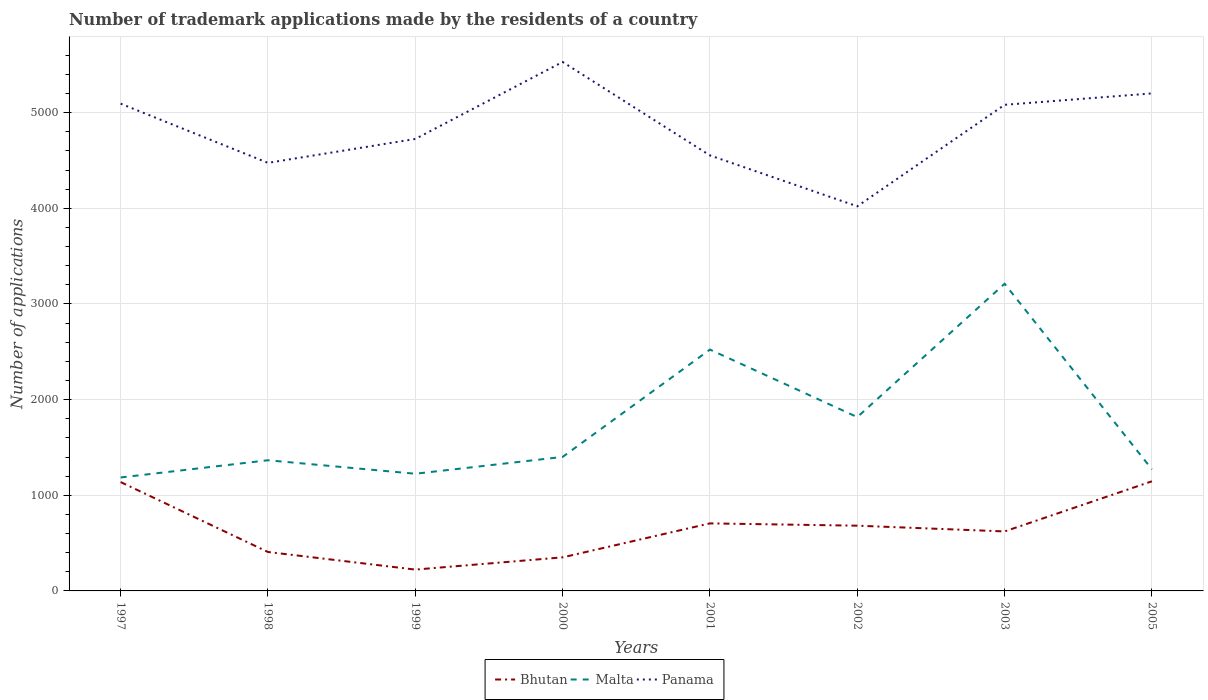How many different coloured lines are there?
Keep it short and to the point. 3. Does the line corresponding to Panama intersect with the line corresponding to Bhutan?
Your answer should be compact. No. Across all years, what is the maximum number of trademark applications made by the residents in Panama?
Your answer should be very brief. 4021. What is the total number of trademark applications made by the residents in Panama in the graph?
Make the answer very short. -726. What is the difference between the highest and the second highest number of trademark applications made by the residents in Panama?
Make the answer very short. 1509. How many years are there in the graph?
Offer a terse response. 8. What is the difference between two consecutive major ticks on the Y-axis?
Your answer should be very brief. 1000. How are the legend labels stacked?
Provide a short and direct response. Horizontal. What is the title of the graph?
Your response must be concise. Number of trademark applications made by the residents of a country. What is the label or title of the X-axis?
Make the answer very short. Years. What is the label or title of the Y-axis?
Offer a terse response. Number of applications. What is the Number of applications in Bhutan in 1997?
Give a very brief answer. 1138. What is the Number of applications in Malta in 1997?
Offer a terse response. 1186. What is the Number of applications in Panama in 1997?
Offer a terse response. 5094. What is the Number of applications in Bhutan in 1998?
Make the answer very short. 407. What is the Number of applications of Malta in 1998?
Offer a very short reply. 1366. What is the Number of applications in Panama in 1998?
Ensure brevity in your answer.  4475. What is the Number of applications of Bhutan in 1999?
Provide a succinct answer. 223. What is the Number of applications of Malta in 1999?
Give a very brief answer. 1225. What is the Number of applications of Panama in 1999?
Provide a succinct answer. 4725. What is the Number of applications of Bhutan in 2000?
Provide a succinct answer. 351. What is the Number of applications in Malta in 2000?
Your answer should be compact. 1401. What is the Number of applications of Panama in 2000?
Your answer should be compact. 5530. What is the Number of applications in Bhutan in 2001?
Offer a terse response. 706. What is the Number of applications of Malta in 2001?
Make the answer very short. 2523. What is the Number of applications in Panama in 2001?
Make the answer very short. 4553. What is the Number of applications of Bhutan in 2002?
Provide a succinct answer. 682. What is the Number of applications of Malta in 2002?
Your answer should be very brief. 1817. What is the Number of applications of Panama in 2002?
Make the answer very short. 4021. What is the Number of applications of Bhutan in 2003?
Keep it short and to the point. 622. What is the Number of applications of Malta in 2003?
Keep it short and to the point. 3211. What is the Number of applications in Panama in 2003?
Your answer should be compact. 5082. What is the Number of applications of Bhutan in 2005?
Provide a succinct answer. 1146. What is the Number of applications of Malta in 2005?
Make the answer very short. 1271. What is the Number of applications in Panama in 2005?
Give a very brief answer. 5201. Across all years, what is the maximum Number of applications of Bhutan?
Provide a succinct answer. 1146. Across all years, what is the maximum Number of applications of Malta?
Make the answer very short. 3211. Across all years, what is the maximum Number of applications of Panama?
Keep it short and to the point. 5530. Across all years, what is the minimum Number of applications in Bhutan?
Give a very brief answer. 223. Across all years, what is the minimum Number of applications in Malta?
Offer a very short reply. 1186. Across all years, what is the minimum Number of applications of Panama?
Your response must be concise. 4021. What is the total Number of applications of Bhutan in the graph?
Offer a very short reply. 5275. What is the total Number of applications in Malta in the graph?
Provide a short and direct response. 1.40e+04. What is the total Number of applications in Panama in the graph?
Ensure brevity in your answer.  3.87e+04. What is the difference between the Number of applications of Bhutan in 1997 and that in 1998?
Provide a short and direct response. 731. What is the difference between the Number of applications in Malta in 1997 and that in 1998?
Your answer should be very brief. -180. What is the difference between the Number of applications of Panama in 1997 and that in 1998?
Your response must be concise. 619. What is the difference between the Number of applications in Bhutan in 1997 and that in 1999?
Your answer should be compact. 915. What is the difference between the Number of applications of Malta in 1997 and that in 1999?
Your answer should be compact. -39. What is the difference between the Number of applications of Panama in 1997 and that in 1999?
Give a very brief answer. 369. What is the difference between the Number of applications in Bhutan in 1997 and that in 2000?
Your answer should be very brief. 787. What is the difference between the Number of applications of Malta in 1997 and that in 2000?
Make the answer very short. -215. What is the difference between the Number of applications in Panama in 1997 and that in 2000?
Ensure brevity in your answer.  -436. What is the difference between the Number of applications of Bhutan in 1997 and that in 2001?
Ensure brevity in your answer.  432. What is the difference between the Number of applications of Malta in 1997 and that in 2001?
Ensure brevity in your answer.  -1337. What is the difference between the Number of applications in Panama in 1997 and that in 2001?
Provide a short and direct response. 541. What is the difference between the Number of applications in Bhutan in 1997 and that in 2002?
Provide a succinct answer. 456. What is the difference between the Number of applications in Malta in 1997 and that in 2002?
Make the answer very short. -631. What is the difference between the Number of applications of Panama in 1997 and that in 2002?
Make the answer very short. 1073. What is the difference between the Number of applications of Bhutan in 1997 and that in 2003?
Provide a succinct answer. 516. What is the difference between the Number of applications in Malta in 1997 and that in 2003?
Make the answer very short. -2025. What is the difference between the Number of applications of Bhutan in 1997 and that in 2005?
Provide a succinct answer. -8. What is the difference between the Number of applications in Malta in 1997 and that in 2005?
Ensure brevity in your answer.  -85. What is the difference between the Number of applications of Panama in 1997 and that in 2005?
Provide a short and direct response. -107. What is the difference between the Number of applications of Bhutan in 1998 and that in 1999?
Ensure brevity in your answer.  184. What is the difference between the Number of applications in Malta in 1998 and that in 1999?
Keep it short and to the point. 141. What is the difference between the Number of applications in Panama in 1998 and that in 1999?
Give a very brief answer. -250. What is the difference between the Number of applications of Malta in 1998 and that in 2000?
Ensure brevity in your answer.  -35. What is the difference between the Number of applications in Panama in 1998 and that in 2000?
Keep it short and to the point. -1055. What is the difference between the Number of applications in Bhutan in 1998 and that in 2001?
Offer a very short reply. -299. What is the difference between the Number of applications in Malta in 1998 and that in 2001?
Offer a terse response. -1157. What is the difference between the Number of applications of Panama in 1998 and that in 2001?
Your response must be concise. -78. What is the difference between the Number of applications in Bhutan in 1998 and that in 2002?
Your response must be concise. -275. What is the difference between the Number of applications in Malta in 1998 and that in 2002?
Your answer should be very brief. -451. What is the difference between the Number of applications of Panama in 1998 and that in 2002?
Provide a succinct answer. 454. What is the difference between the Number of applications in Bhutan in 1998 and that in 2003?
Your answer should be compact. -215. What is the difference between the Number of applications of Malta in 1998 and that in 2003?
Offer a very short reply. -1845. What is the difference between the Number of applications in Panama in 1998 and that in 2003?
Your answer should be compact. -607. What is the difference between the Number of applications in Bhutan in 1998 and that in 2005?
Your answer should be compact. -739. What is the difference between the Number of applications of Malta in 1998 and that in 2005?
Make the answer very short. 95. What is the difference between the Number of applications in Panama in 1998 and that in 2005?
Offer a very short reply. -726. What is the difference between the Number of applications of Bhutan in 1999 and that in 2000?
Your answer should be very brief. -128. What is the difference between the Number of applications in Malta in 1999 and that in 2000?
Your response must be concise. -176. What is the difference between the Number of applications in Panama in 1999 and that in 2000?
Keep it short and to the point. -805. What is the difference between the Number of applications in Bhutan in 1999 and that in 2001?
Your response must be concise. -483. What is the difference between the Number of applications in Malta in 1999 and that in 2001?
Make the answer very short. -1298. What is the difference between the Number of applications of Panama in 1999 and that in 2001?
Your answer should be very brief. 172. What is the difference between the Number of applications in Bhutan in 1999 and that in 2002?
Make the answer very short. -459. What is the difference between the Number of applications of Malta in 1999 and that in 2002?
Your response must be concise. -592. What is the difference between the Number of applications in Panama in 1999 and that in 2002?
Provide a short and direct response. 704. What is the difference between the Number of applications of Bhutan in 1999 and that in 2003?
Offer a very short reply. -399. What is the difference between the Number of applications of Malta in 1999 and that in 2003?
Make the answer very short. -1986. What is the difference between the Number of applications in Panama in 1999 and that in 2003?
Your answer should be compact. -357. What is the difference between the Number of applications in Bhutan in 1999 and that in 2005?
Keep it short and to the point. -923. What is the difference between the Number of applications of Malta in 1999 and that in 2005?
Your response must be concise. -46. What is the difference between the Number of applications in Panama in 1999 and that in 2005?
Provide a succinct answer. -476. What is the difference between the Number of applications in Bhutan in 2000 and that in 2001?
Give a very brief answer. -355. What is the difference between the Number of applications in Malta in 2000 and that in 2001?
Provide a succinct answer. -1122. What is the difference between the Number of applications in Panama in 2000 and that in 2001?
Make the answer very short. 977. What is the difference between the Number of applications in Bhutan in 2000 and that in 2002?
Provide a short and direct response. -331. What is the difference between the Number of applications of Malta in 2000 and that in 2002?
Provide a succinct answer. -416. What is the difference between the Number of applications in Panama in 2000 and that in 2002?
Offer a very short reply. 1509. What is the difference between the Number of applications of Bhutan in 2000 and that in 2003?
Your answer should be very brief. -271. What is the difference between the Number of applications of Malta in 2000 and that in 2003?
Keep it short and to the point. -1810. What is the difference between the Number of applications in Panama in 2000 and that in 2003?
Provide a succinct answer. 448. What is the difference between the Number of applications in Bhutan in 2000 and that in 2005?
Ensure brevity in your answer.  -795. What is the difference between the Number of applications in Malta in 2000 and that in 2005?
Give a very brief answer. 130. What is the difference between the Number of applications of Panama in 2000 and that in 2005?
Offer a terse response. 329. What is the difference between the Number of applications of Bhutan in 2001 and that in 2002?
Your response must be concise. 24. What is the difference between the Number of applications in Malta in 2001 and that in 2002?
Provide a succinct answer. 706. What is the difference between the Number of applications in Panama in 2001 and that in 2002?
Your answer should be compact. 532. What is the difference between the Number of applications of Bhutan in 2001 and that in 2003?
Offer a terse response. 84. What is the difference between the Number of applications of Malta in 2001 and that in 2003?
Provide a short and direct response. -688. What is the difference between the Number of applications of Panama in 2001 and that in 2003?
Your answer should be very brief. -529. What is the difference between the Number of applications of Bhutan in 2001 and that in 2005?
Your response must be concise. -440. What is the difference between the Number of applications in Malta in 2001 and that in 2005?
Give a very brief answer. 1252. What is the difference between the Number of applications of Panama in 2001 and that in 2005?
Give a very brief answer. -648. What is the difference between the Number of applications in Malta in 2002 and that in 2003?
Your response must be concise. -1394. What is the difference between the Number of applications in Panama in 2002 and that in 2003?
Offer a very short reply. -1061. What is the difference between the Number of applications in Bhutan in 2002 and that in 2005?
Ensure brevity in your answer.  -464. What is the difference between the Number of applications in Malta in 2002 and that in 2005?
Keep it short and to the point. 546. What is the difference between the Number of applications of Panama in 2002 and that in 2005?
Your response must be concise. -1180. What is the difference between the Number of applications of Bhutan in 2003 and that in 2005?
Ensure brevity in your answer.  -524. What is the difference between the Number of applications in Malta in 2003 and that in 2005?
Offer a terse response. 1940. What is the difference between the Number of applications of Panama in 2003 and that in 2005?
Your answer should be very brief. -119. What is the difference between the Number of applications in Bhutan in 1997 and the Number of applications in Malta in 1998?
Keep it short and to the point. -228. What is the difference between the Number of applications in Bhutan in 1997 and the Number of applications in Panama in 1998?
Ensure brevity in your answer.  -3337. What is the difference between the Number of applications of Malta in 1997 and the Number of applications of Panama in 1998?
Ensure brevity in your answer.  -3289. What is the difference between the Number of applications of Bhutan in 1997 and the Number of applications of Malta in 1999?
Your answer should be very brief. -87. What is the difference between the Number of applications of Bhutan in 1997 and the Number of applications of Panama in 1999?
Offer a very short reply. -3587. What is the difference between the Number of applications in Malta in 1997 and the Number of applications in Panama in 1999?
Provide a succinct answer. -3539. What is the difference between the Number of applications of Bhutan in 1997 and the Number of applications of Malta in 2000?
Offer a terse response. -263. What is the difference between the Number of applications of Bhutan in 1997 and the Number of applications of Panama in 2000?
Ensure brevity in your answer.  -4392. What is the difference between the Number of applications of Malta in 1997 and the Number of applications of Panama in 2000?
Your answer should be very brief. -4344. What is the difference between the Number of applications in Bhutan in 1997 and the Number of applications in Malta in 2001?
Make the answer very short. -1385. What is the difference between the Number of applications of Bhutan in 1997 and the Number of applications of Panama in 2001?
Provide a succinct answer. -3415. What is the difference between the Number of applications in Malta in 1997 and the Number of applications in Panama in 2001?
Make the answer very short. -3367. What is the difference between the Number of applications in Bhutan in 1997 and the Number of applications in Malta in 2002?
Offer a very short reply. -679. What is the difference between the Number of applications of Bhutan in 1997 and the Number of applications of Panama in 2002?
Provide a short and direct response. -2883. What is the difference between the Number of applications of Malta in 1997 and the Number of applications of Panama in 2002?
Provide a succinct answer. -2835. What is the difference between the Number of applications of Bhutan in 1997 and the Number of applications of Malta in 2003?
Offer a very short reply. -2073. What is the difference between the Number of applications in Bhutan in 1997 and the Number of applications in Panama in 2003?
Keep it short and to the point. -3944. What is the difference between the Number of applications of Malta in 1997 and the Number of applications of Panama in 2003?
Offer a terse response. -3896. What is the difference between the Number of applications of Bhutan in 1997 and the Number of applications of Malta in 2005?
Offer a very short reply. -133. What is the difference between the Number of applications of Bhutan in 1997 and the Number of applications of Panama in 2005?
Make the answer very short. -4063. What is the difference between the Number of applications of Malta in 1997 and the Number of applications of Panama in 2005?
Give a very brief answer. -4015. What is the difference between the Number of applications in Bhutan in 1998 and the Number of applications in Malta in 1999?
Provide a short and direct response. -818. What is the difference between the Number of applications of Bhutan in 1998 and the Number of applications of Panama in 1999?
Your response must be concise. -4318. What is the difference between the Number of applications in Malta in 1998 and the Number of applications in Panama in 1999?
Make the answer very short. -3359. What is the difference between the Number of applications of Bhutan in 1998 and the Number of applications of Malta in 2000?
Provide a short and direct response. -994. What is the difference between the Number of applications in Bhutan in 1998 and the Number of applications in Panama in 2000?
Provide a short and direct response. -5123. What is the difference between the Number of applications in Malta in 1998 and the Number of applications in Panama in 2000?
Ensure brevity in your answer.  -4164. What is the difference between the Number of applications in Bhutan in 1998 and the Number of applications in Malta in 2001?
Your response must be concise. -2116. What is the difference between the Number of applications of Bhutan in 1998 and the Number of applications of Panama in 2001?
Make the answer very short. -4146. What is the difference between the Number of applications in Malta in 1998 and the Number of applications in Panama in 2001?
Provide a short and direct response. -3187. What is the difference between the Number of applications of Bhutan in 1998 and the Number of applications of Malta in 2002?
Your answer should be very brief. -1410. What is the difference between the Number of applications in Bhutan in 1998 and the Number of applications in Panama in 2002?
Your response must be concise. -3614. What is the difference between the Number of applications of Malta in 1998 and the Number of applications of Panama in 2002?
Provide a short and direct response. -2655. What is the difference between the Number of applications in Bhutan in 1998 and the Number of applications in Malta in 2003?
Your answer should be very brief. -2804. What is the difference between the Number of applications of Bhutan in 1998 and the Number of applications of Panama in 2003?
Your answer should be compact. -4675. What is the difference between the Number of applications of Malta in 1998 and the Number of applications of Panama in 2003?
Provide a succinct answer. -3716. What is the difference between the Number of applications of Bhutan in 1998 and the Number of applications of Malta in 2005?
Give a very brief answer. -864. What is the difference between the Number of applications in Bhutan in 1998 and the Number of applications in Panama in 2005?
Provide a short and direct response. -4794. What is the difference between the Number of applications in Malta in 1998 and the Number of applications in Panama in 2005?
Offer a terse response. -3835. What is the difference between the Number of applications of Bhutan in 1999 and the Number of applications of Malta in 2000?
Your answer should be very brief. -1178. What is the difference between the Number of applications of Bhutan in 1999 and the Number of applications of Panama in 2000?
Provide a short and direct response. -5307. What is the difference between the Number of applications of Malta in 1999 and the Number of applications of Panama in 2000?
Provide a succinct answer. -4305. What is the difference between the Number of applications in Bhutan in 1999 and the Number of applications in Malta in 2001?
Ensure brevity in your answer.  -2300. What is the difference between the Number of applications in Bhutan in 1999 and the Number of applications in Panama in 2001?
Give a very brief answer. -4330. What is the difference between the Number of applications in Malta in 1999 and the Number of applications in Panama in 2001?
Make the answer very short. -3328. What is the difference between the Number of applications of Bhutan in 1999 and the Number of applications of Malta in 2002?
Provide a succinct answer. -1594. What is the difference between the Number of applications of Bhutan in 1999 and the Number of applications of Panama in 2002?
Give a very brief answer. -3798. What is the difference between the Number of applications in Malta in 1999 and the Number of applications in Panama in 2002?
Provide a short and direct response. -2796. What is the difference between the Number of applications of Bhutan in 1999 and the Number of applications of Malta in 2003?
Offer a very short reply. -2988. What is the difference between the Number of applications of Bhutan in 1999 and the Number of applications of Panama in 2003?
Ensure brevity in your answer.  -4859. What is the difference between the Number of applications of Malta in 1999 and the Number of applications of Panama in 2003?
Provide a succinct answer. -3857. What is the difference between the Number of applications of Bhutan in 1999 and the Number of applications of Malta in 2005?
Provide a short and direct response. -1048. What is the difference between the Number of applications in Bhutan in 1999 and the Number of applications in Panama in 2005?
Ensure brevity in your answer.  -4978. What is the difference between the Number of applications of Malta in 1999 and the Number of applications of Panama in 2005?
Provide a succinct answer. -3976. What is the difference between the Number of applications of Bhutan in 2000 and the Number of applications of Malta in 2001?
Your response must be concise. -2172. What is the difference between the Number of applications of Bhutan in 2000 and the Number of applications of Panama in 2001?
Your response must be concise. -4202. What is the difference between the Number of applications in Malta in 2000 and the Number of applications in Panama in 2001?
Ensure brevity in your answer.  -3152. What is the difference between the Number of applications in Bhutan in 2000 and the Number of applications in Malta in 2002?
Your answer should be compact. -1466. What is the difference between the Number of applications in Bhutan in 2000 and the Number of applications in Panama in 2002?
Your response must be concise. -3670. What is the difference between the Number of applications in Malta in 2000 and the Number of applications in Panama in 2002?
Make the answer very short. -2620. What is the difference between the Number of applications of Bhutan in 2000 and the Number of applications of Malta in 2003?
Your response must be concise. -2860. What is the difference between the Number of applications of Bhutan in 2000 and the Number of applications of Panama in 2003?
Make the answer very short. -4731. What is the difference between the Number of applications in Malta in 2000 and the Number of applications in Panama in 2003?
Make the answer very short. -3681. What is the difference between the Number of applications in Bhutan in 2000 and the Number of applications in Malta in 2005?
Keep it short and to the point. -920. What is the difference between the Number of applications in Bhutan in 2000 and the Number of applications in Panama in 2005?
Provide a succinct answer. -4850. What is the difference between the Number of applications of Malta in 2000 and the Number of applications of Panama in 2005?
Your answer should be very brief. -3800. What is the difference between the Number of applications in Bhutan in 2001 and the Number of applications in Malta in 2002?
Provide a succinct answer. -1111. What is the difference between the Number of applications of Bhutan in 2001 and the Number of applications of Panama in 2002?
Keep it short and to the point. -3315. What is the difference between the Number of applications in Malta in 2001 and the Number of applications in Panama in 2002?
Ensure brevity in your answer.  -1498. What is the difference between the Number of applications of Bhutan in 2001 and the Number of applications of Malta in 2003?
Make the answer very short. -2505. What is the difference between the Number of applications of Bhutan in 2001 and the Number of applications of Panama in 2003?
Your answer should be compact. -4376. What is the difference between the Number of applications of Malta in 2001 and the Number of applications of Panama in 2003?
Provide a succinct answer. -2559. What is the difference between the Number of applications of Bhutan in 2001 and the Number of applications of Malta in 2005?
Your answer should be compact. -565. What is the difference between the Number of applications of Bhutan in 2001 and the Number of applications of Panama in 2005?
Offer a very short reply. -4495. What is the difference between the Number of applications of Malta in 2001 and the Number of applications of Panama in 2005?
Keep it short and to the point. -2678. What is the difference between the Number of applications in Bhutan in 2002 and the Number of applications in Malta in 2003?
Keep it short and to the point. -2529. What is the difference between the Number of applications in Bhutan in 2002 and the Number of applications in Panama in 2003?
Provide a short and direct response. -4400. What is the difference between the Number of applications in Malta in 2002 and the Number of applications in Panama in 2003?
Your answer should be very brief. -3265. What is the difference between the Number of applications in Bhutan in 2002 and the Number of applications in Malta in 2005?
Offer a very short reply. -589. What is the difference between the Number of applications of Bhutan in 2002 and the Number of applications of Panama in 2005?
Make the answer very short. -4519. What is the difference between the Number of applications of Malta in 2002 and the Number of applications of Panama in 2005?
Your answer should be very brief. -3384. What is the difference between the Number of applications in Bhutan in 2003 and the Number of applications in Malta in 2005?
Your answer should be very brief. -649. What is the difference between the Number of applications of Bhutan in 2003 and the Number of applications of Panama in 2005?
Provide a short and direct response. -4579. What is the difference between the Number of applications of Malta in 2003 and the Number of applications of Panama in 2005?
Your answer should be compact. -1990. What is the average Number of applications in Bhutan per year?
Make the answer very short. 659.38. What is the average Number of applications of Malta per year?
Give a very brief answer. 1750. What is the average Number of applications in Panama per year?
Your answer should be compact. 4835.12. In the year 1997, what is the difference between the Number of applications of Bhutan and Number of applications of Malta?
Provide a short and direct response. -48. In the year 1997, what is the difference between the Number of applications of Bhutan and Number of applications of Panama?
Offer a terse response. -3956. In the year 1997, what is the difference between the Number of applications in Malta and Number of applications in Panama?
Offer a terse response. -3908. In the year 1998, what is the difference between the Number of applications of Bhutan and Number of applications of Malta?
Keep it short and to the point. -959. In the year 1998, what is the difference between the Number of applications of Bhutan and Number of applications of Panama?
Keep it short and to the point. -4068. In the year 1998, what is the difference between the Number of applications of Malta and Number of applications of Panama?
Your answer should be very brief. -3109. In the year 1999, what is the difference between the Number of applications of Bhutan and Number of applications of Malta?
Ensure brevity in your answer.  -1002. In the year 1999, what is the difference between the Number of applications of Bhutan and Number of applications of Panama?
Your answer should be compact. -4502. In the year 1999, what is the difference between the Number of applications in Malta and Number of applications in Panama?
Ensure brevity in your answer.  -3500. In the year 2000, what is the difference between the Number of applications of Bhutan and Number of applications of Malta?
Offer a terse response. -1050. In the year 2000, what is the difference between the Number of applications in Bhutan and Number of applications in Panama?
Your answer should be very brief. -5179. In the year 2000, what is the difference between the Number of applications of Malta and Number of applications of Panama?
Offer a terse response. -4129. In the year 2001, what is the difference between the Number of applications in Bhutan and Number of applications in Malta?
Your answer should be very brief. -1817. In the year 2001, what is the difference between the Number of applications in Bhutan and Number of applications in Panama?
Provide a short and direct response. -3847. In the year 2001, what is the difference between the Number of applications of Malta and Number of applications of Panama?
Ensure brevity in your answer.  -2030. In the year 2002, what is the difference between the Number of applications in Bhutan and Number of applications in Malta?
Offer a terse response. -1135. In the year 2002, what is the difference between the Number of applications of Bhutan and Number of applications of Panama?
Keep it short and to the point. -3339. In the year 2002, what is the difference between the Number of applications of Malta and Number of applications of Panama?
Offer a very short reply. -2204. In the year 2003, what is the difference between the Number of applications of Bhutan and Number of applications of Malta?
Ensure brevity in your answer.  -2589. In the year 2003, what is the difference between the Number of applications in Bhutan and Number of applications in Panama?
Provide a short and direct response. -4460. In the year 2003, what is the difference between the Number of applications of Malta and Number of applications of Panama?
Ensure brevity in your answer.  -1871. In the year 2005, what is the difference between the Number of applications of Bhutan and Number of applications of Malta?
Your response must be concise. -125. In the year 2005, what is the difference between the Number of applications of Bhutan and Number of applications of Panama?
Offer a very short reply. -4055. In the year 2005, what is the difference between the Number of applications of Malta and Number of applications of Panama?
Offer a terse response. -3930. What is the ratio of the Number of applications of Bhutan in 1997 to that in 1998?
Provide a succinct answer. 2.8. What is the ratio of the Number of applications in Malta in 1997 to that in 1998?
Provide a succinct answer. 0.87. What is the ratio of the Number of applications in Panama in 1997 to that in 1998?
Your answer should be very brief. 1.14. What is the ratio of the Number of applications in Bhutan in 1997 to that in 1999?
Keep it short and to the point. 5.1. What is the ratio of the Number of applications in Malta in 1997 to that in 1999?
Ensure brevity in your answer.  0.97. What is the ratio of the Number of applications of Panama in 1997 to that in 1999?
Provide a short and direct response. 1.08. What is the ratio of the Number of applications of Bhutan in 1997 to that in 2000?
Offer a very short reply. 3.24. What is the ratio of the Number of applications of Malta in 1997 to that in 2000?
Offer a very short reply. 0.85. What is the ratio of the Number of applications of Panama in 1997 to that in 2000?
Your answer should be compact. 0.92. What is the ratio of the Number of applications of Bhutan in 1997 to that in 2001?
Ensure brevity in your answer.  1.61. What is the ratio of the Number of applications in Malta in 1997 to that in 2001?
Make the answer very short. 0.47. What is the ratio of the Number of applications in Panama in 1997 to that in 2001?
Provide a short and direct response. 1.12. What is the ratio of the Number of applications in Bhutan in 1997 to that in 2002?
Provide a succinct answer. 1.67. What is the ratio of the Number of applications in Malta in 1997 to that in 2002?
Your answer should be compact. 0.65. What is the ratio of the Number of applications in Panama in 1997 to that in 2002?
Keep it short and to the point. 1.27. What is the ratio of the Number of applications of Bhutan in 1997 to that in 2003?
Keep it short and to the point. 1.83. What is the ratio of the Number of applications in Malta in 1997 to that in 2003?
Provide a short and direct response. 0.37. What is the ratio of the Number of applications of Panama in 1997 to that in 2003?
Keep it short and to the point. 1. What is the ratio of the Number of applications of Malta in 1997 to that in 2005?
Offer a terse response. 0.93. What is the ratio of the Number of applications of Panama in 1997 to that in 2005?
Your answer should be very brief. 0.98. What is the ratio of the Number of applications of Bhutan in 1998 to that in 1999?
Offer a very short reply. 1.83. What is the ratio of the Number of applications of Malta in 1998 to that in 1999?
Your answer should be compact. 1.12. What is the ratio of the Number of applications in Panama in 1998 to that in 1999?
Ensure brevity in your answer.  0.95. What is the ratio of the Number of applications of Bhutan in 1998 to that in 2000?
Make the answer very short. 1.16. What is the ratio of the Number of applications of Malta in 1998 to that in 2000?
Offer a very short reply. 0.97. What is the ratio of the Number of applications in Panama in 1998 to that in 2000?
Offer a terse response. 0.81. What is the ratio of the Number of applications of Bhutan in 1998 to that in 2001?
Offer a very short reply. 0.58. What is the ratio of the Number of applications in Malta in 1998 to that in 2001?
Give a very brief answer. 0.54. What is the ratio of the Number of applications of Panama in 1998 to that in 2001?
Provide a succinct answer. 0.98. What is the ratio of the Number of applications in Bhutan in 1998 to that in 2002?
Provide a short and direct response. 0.6. What is the ratio of the Number of applications in Malta in 1998 to that in 2002?
Your response must be concise. 0.75. What is the ratio of the Number of applications of Panama in 1998 to that in 2002?
Provide a succinct answer. 1.11. What is the ratio of the Number of applications in Bhutan in 1998 to that in 2003?
Your answer should be very brief. 0.65. What is the ratio of the Number of applications of Malta in 1998 to that in 2003?
Make the answer very short. 0.43. What is the ratio of the Number of applications of Panama in 1998 to that in 2003?
Offer a very short reply. 0.88. What is the ratio of the Number of applications in Bhutan in 1998 to that in 2005?
Your answer should be compact. 0.36. What is the ratio of the Number of applications of Malta in 1998 to that in 2005?
Offer a terse response. 1.07. What is the ratio of the Number of applications in Panama in 1998 to that in 2005?
Your answer should be very brief. 0.86. What is the ratio of the Number of applications in Bhutan in 1999 to that in 2000?
Ensure brevity in your answer.  0.64. What is the ratio of the Number of applications of Malta in 1999 to that in 2000?
Provide a succinct answer. 0.87. What is the ratio of the Number of applications of Panama in 1999 to that in 2000?
Provide a succinct answer. 0.85. What is the ratio of the Number of applications in Bhutan in 1999 to that in 2001?
Your response must be concise. 0.32. What is the ratio of the Number of applications in Malta in 1999 to that in 2001?
Your answer should be very brief. 0.49. What is the ratio of the Number of applications of Panama in 1999 to that in 2001?
Keep it short and to the point. 1.04. What is the ratio of the Number of applications in Bhutan in 1999 to that in 2002?
Ensure brevity in your answer.  0.33. What is the ratio of the Number of applications of Malta in 1999 to that in 2002?
Offer a terse response. 0.67. What is the ratio of the Number of applications in Panama in 1999 to that in 2002?
Your response must be concise. 1.18. What is the ratio of the Number of applications in Bhutan in 1999 to that in 2003?
Your response must be concise. 0.36. What is the ratio of the Number of applications of Malta in 1999 to that in 2003?
Offer a terse response. 0.38. What is the ratio of the Number of applications of Panama in 1999 to that in 2003?
Make the answer very short. 0.93. What is the ratio of the Number of applications of Bhutan in 1999 to that in 2005?
Provide a short and direct response. 0.19. What is the ratio of the Number of applications in Malta in 1999 to that in 2005?
Keep it short and to the point. 0.96. What is the ratio of the Number of applications of Panama in 1999 to that in 2005?
Provide a short and direct response. 0.91. What is the ratio of the Number of applications in Bhutan in 2000 to that in 2001?
Ensure brevity in your answer.  0.5. What is the ratio of the Number of applications in Malta in 2000 to that in 2001?
Give a very brief answer. 0.56. What is the ratio of the Number of applications of Panama in 2000 to that in 2001?
Keep it short and to the point. 1.21. What is the ratio of the Number of applications in Bhutan in 2000 to that in 2002?
Offer a very short reply. 0.51. What is the ratio of the Number of applications in Malta in 2000 to that in 2002?
Provide a succinct answer. 0.77. What is the ratio of the Number of applications in Panama in 2000 to that in 2002?
Offer a terse response. 1.38. What is the ratio of the Number of applications in Bhutan in 2000 to that in 2003?
Provide a succinct answer. 0.56. What is the ratio of the Number of applications in Malta in 2000 to that in 2003?
Offer a terse response. 0.44. What is the ratio of the Number of applications in Panama in 2000 to that in 2003?
Provide a short and direct response. 1.09. What is the ratio of the Number of applications of Bhutan in 2000 to that in 2005?
Your answer should be compact. 0.31. What is the ratio of the Number of applications of Malta in 2000 to that in 2005?
Ensure brevity in your answer.  1.1. What is the ratio of the Number of applications in Panama in 2000 to that in 2005?
Your answer should be very brief. 1.06. What is the ratio of the Number of applications of Bhutan in 2001 to that in 2002?
Provide a short and direct response. 1.04. What is the ratio of the Number of applications of Malta in 2001 to that in 2002?
Give a very brief answer. 1.39. What is the ratio of the Number of applications in Panama in 2001 to that in 2002?
Ensure brevity in your answer.  1.13. What is the ratio of the Number of applications in Bhutan in 2001 to that in 2003?
Your answer should be very brief. 1.14. What is the ratio of the Number of applications of Malta in 2001 to that in 2003?
Provide a succinct answer. 0.79. What is the ratio of the Number of applications in Panama in 2001 to that in 2003?
Make the answer very short. 0.9. What is the ratio of the Number of applications of Bhutan in 2001 to that in 2005?
Your answer should be very brief. 0.62. What is the ratio of the Number of applications in Malta in 2001 to that in 2005?
Offer a terse response. 1.99. What is the ratio of the Number of applications in Panama in 2001 to that in 2005?
Give a very brief answer. 0.88. What is the ratio of the Number of applications in Bhutan in 2002 to that in 2003?
Provide a succinct answer. 1.1. What is the ratio of the Number of applications in Malta in 2002 to that in 2003?
Offer a very short reply. 0.57. What is the ratio of the Number of applications of Panama in 2002 to that in 2003?
Your answer should be very brief. 0.79. What is the ratio of the Number of applications of Bhutan in 2002 to that in 2005?
Your answer should be very brief. 0.6. What is the ratio of the Number of applications of Malta in 2002 to that in 2005?
Give a very brief answer. 1.43. What is the ratio of the Number of applications in Panama in 2002 to that in 2005?
Offer a very short reply. 0.77. What is the ratio of the Number of applications of Bhutan in 2003 to that in 2005?
Keep it short and to the point. 0.54. What is the ratio of the Number of applications in Malta in 2003 to that in 2005?
Provide a succinct answer. 2.53. What is the ratio of the Number of applications in Panama in 2003 to that in 2005?
Provide a succinct answer. 0.98. What is the difference between the highest and the second highest Number of applications in Bhutan?
Make the answer very short. 8. What is the difference between the highest and the second highest Number of applications of Malta?
Offer a very short reply. 688. What is the difference between the highest and the second highest Number of applications in Panama?
Keep it short and to the point. 329. What is the difference between the highest and the lowest Number of applications in Bhutan?
Offer a very short reply. 923. What is the difference between the highest and the lowest Number of applications in Malta?
Give a very brief answer. 2025. What is the difference between the highest and the lowest Number of applications of Panama?
Offer a very short reply. 1509. 